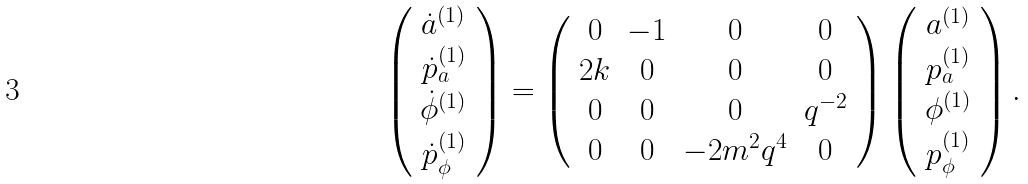<formula> <loc_0><loc_0><loc_500><loc_500>\left ( \begin{array} { c } \dot { a } ^ { ( 1 ) } \\ \dot { p } _ { a } ^ { ( 1 ) } \\ \dot { \phi } ^ { ( 1 ) } \\ \dot { p } _ { \phi } ^ { ( 1 ) } \end{array} \right ) = \left ( \begin{array} { c c c c } 0 & - 1 & 0 & 0 \\ 2 k & 0 & 0 & 0 \\ 0 & 0 & 0 & q ^ { - 2 } \\ 0 & 0 & - 2 m ^ { 2 } q ^ { 4 } & 0 \end{array} \right ) \left ( \begin{array} { c } a ^ { ( 1 ) } \\ p _ { a } ^ { ( 1 ) } \\ \phi ^ { ( 1 ) } \\ p _ { \phi } ^ { ( 1 ) } \end{array} \right ) .</formula> 